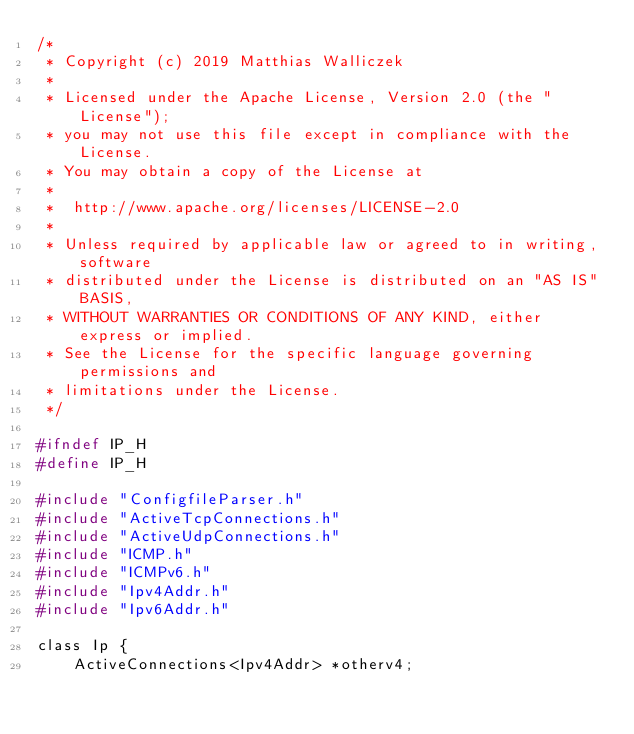<code> <loc_0><loc_0><loc_500><loc_500><_C_>/*
 * Copyright (c) 2019 Matthias Walliczek
 * 
 * Licensed under the Apache License, Version 2.0 (the "License");
 * you may not use this file except in compliance with the License.
 * You may obtain a copy of the License at
 * 
 *  http://www.apache.org/licenses/LICENSE-2.0
 * 
 * Unless required by applicable law or agreed to in writing, software
 * distributed under the License is distributed on an "AS IS" BASIS,
 * WITHOUT WARRANTIES OR CONDITIONS OF ANY KIND, either express or implied.
 * See the License for the specific language governing permissions and
 * limitations under the License.
 */

#ifndef IP_H
#define IP_H

#include "ConfigfileParser.h"
#include "ActiveTcpConnections.h"
#include "ActiveUdpConnections.h"
#include "ICMP.h"
#include "ICMPv6.h"
#include "Ipv4Addr.h"
#include "Ipv6Addr.h"

class Ip {
    ActiveConnections<Ipv4Addr> *otherv4;</code> 